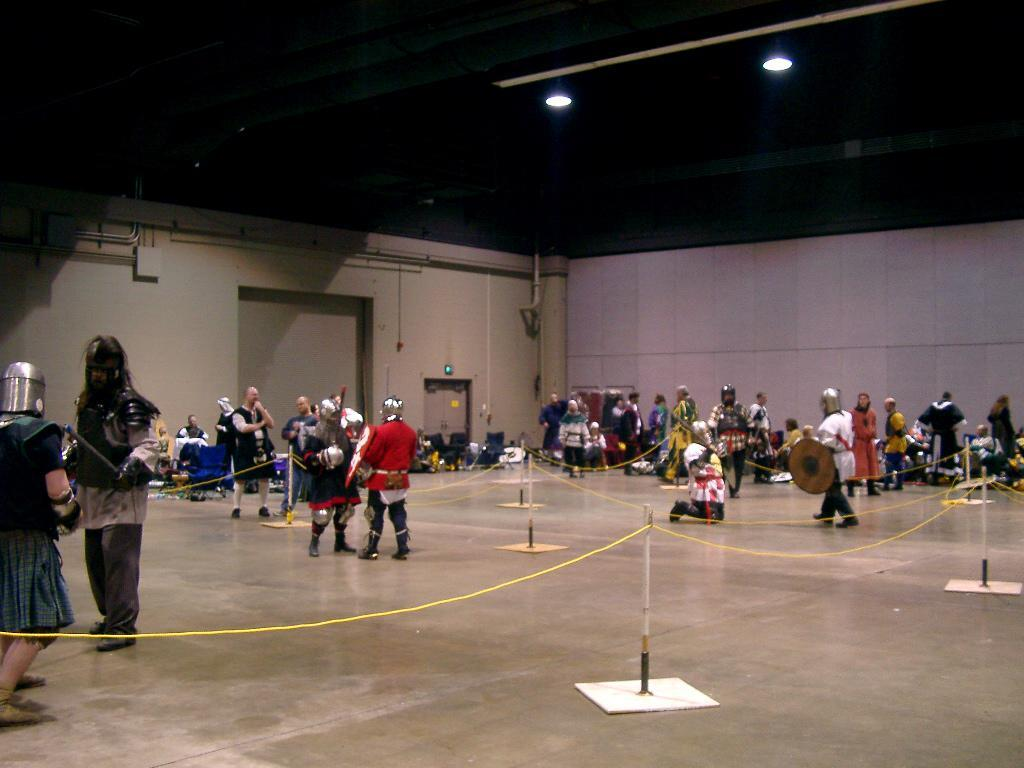How many people are in the image? There are people in the image, but the exact number is not specified. What can be seen supporting the rods in the image? There are rod stands in the image. What are the ropes used for in the image? The purpose of the ropes in the image is not specified. What type of surface is visible in the image? There is a floor visible in the image. What can be seen on the walls in the background of the image? The background of the image includes walls and pipes. What architectural feature is present in the background of the image? There is a door in the background of the image. What other unspecified objects can be seen in the background of the image? There are unspecified objects in the background of the image. What is visible at the top of the image? The top of the image includes lights and pipes. Are there any ghosts visible in the image? There is no mention of ghosts in the provided facts, so it cannot be determined if any are present in the image. What type of territory is being claimed by the people in the image? The provided facts do not mention any territorial claims or disputes, so it cannot be determined if any are present in the image. 